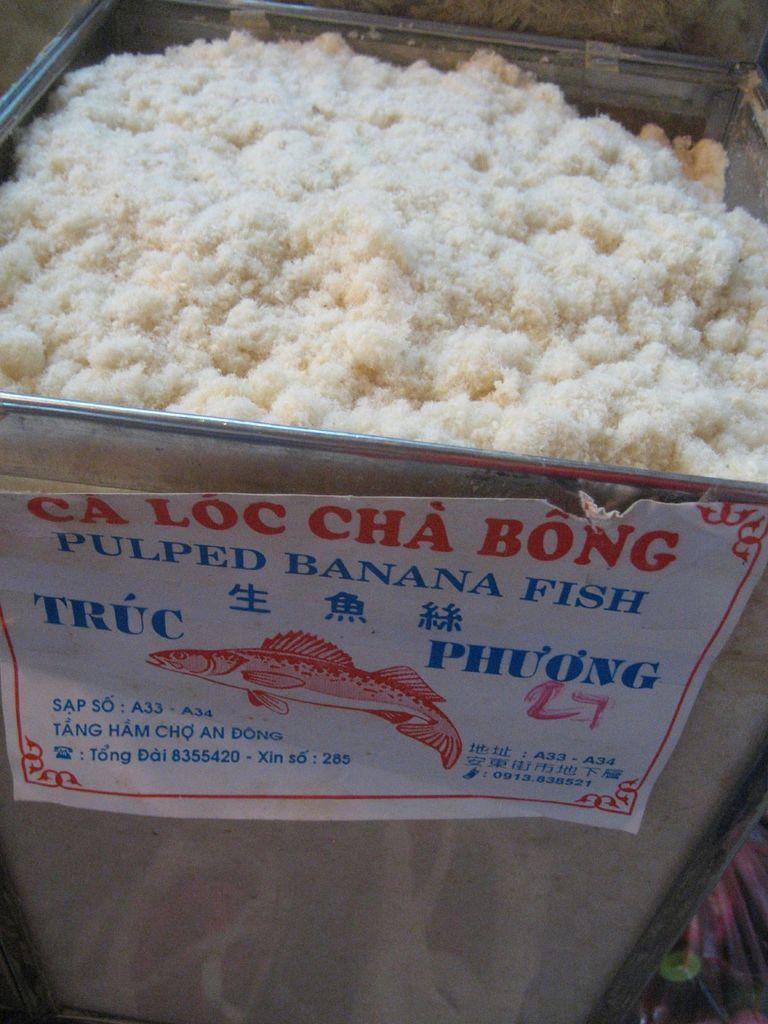Please provide a concise description of this image. In this image we can see a food item in a big container and paper is attached to the container. 